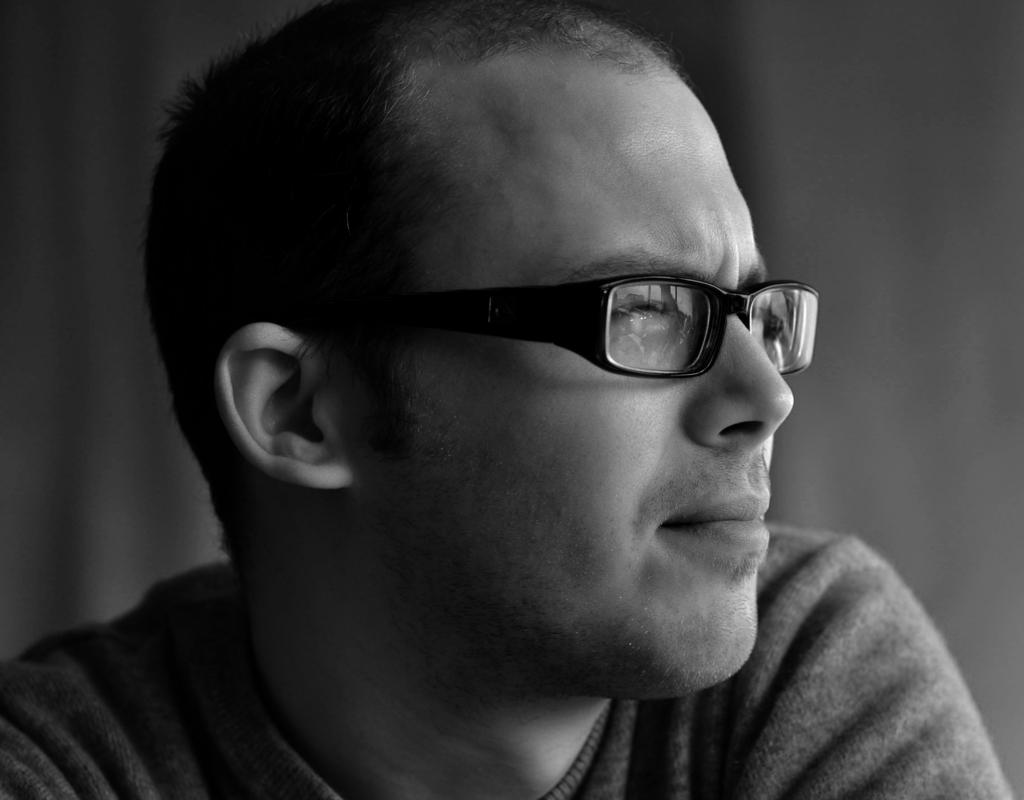What is present in the image? There is a person in the image. Can you describe the person's appearance? The person is wearing spectacles. What type of grip does the person have on the cup in the image? There is no cup present in the image, so it is not possible to determine the person's grip. 